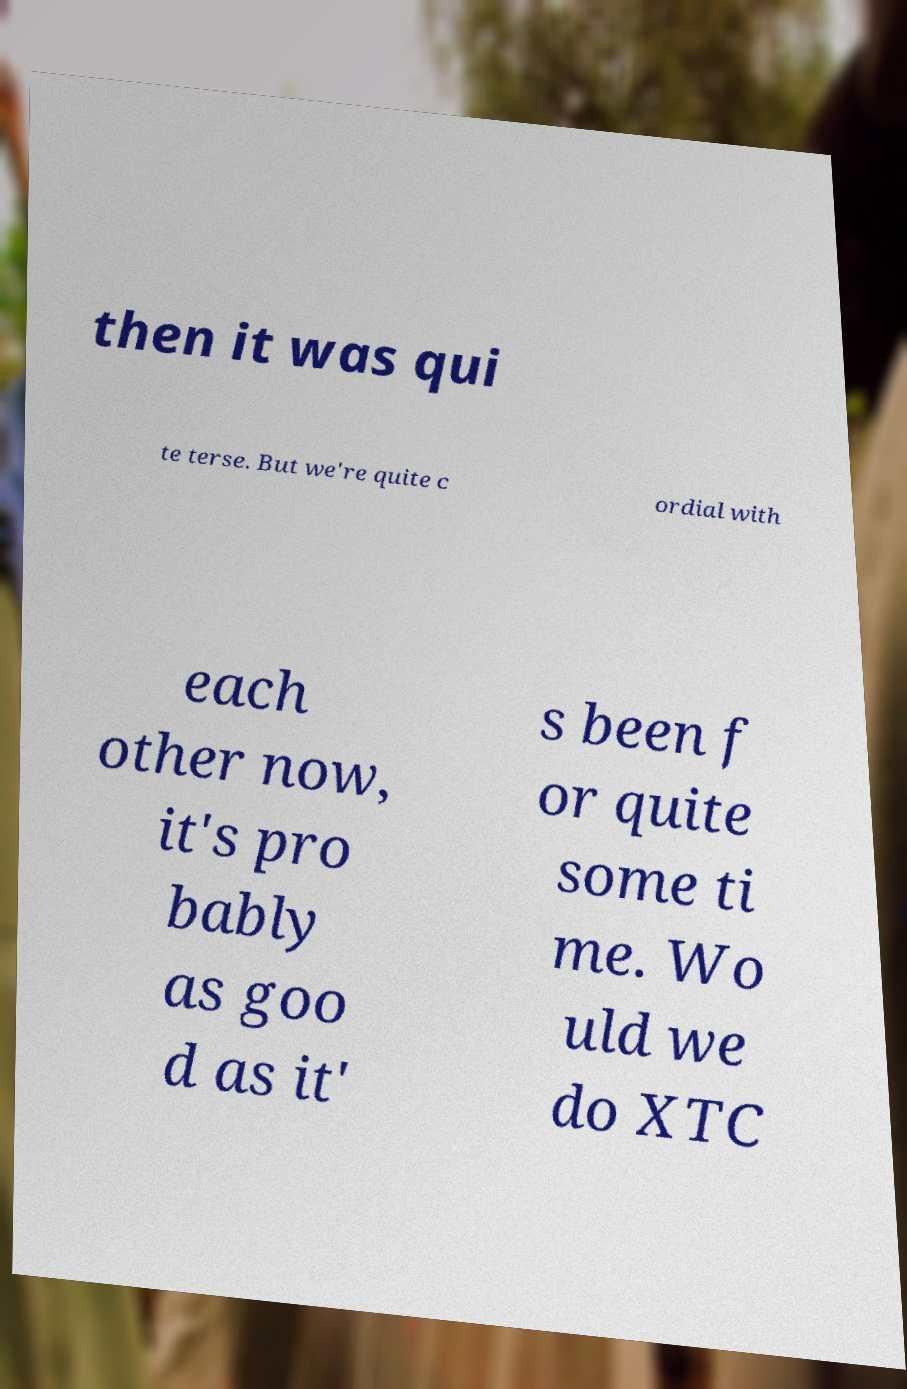I need the written content from this picture converted into text. Can you do that? then it was qui te terse. But we're quite c ordial with each other now, it's pro bably as goo d as it' s been f or quite some ti me. Wo uld we do XTC 